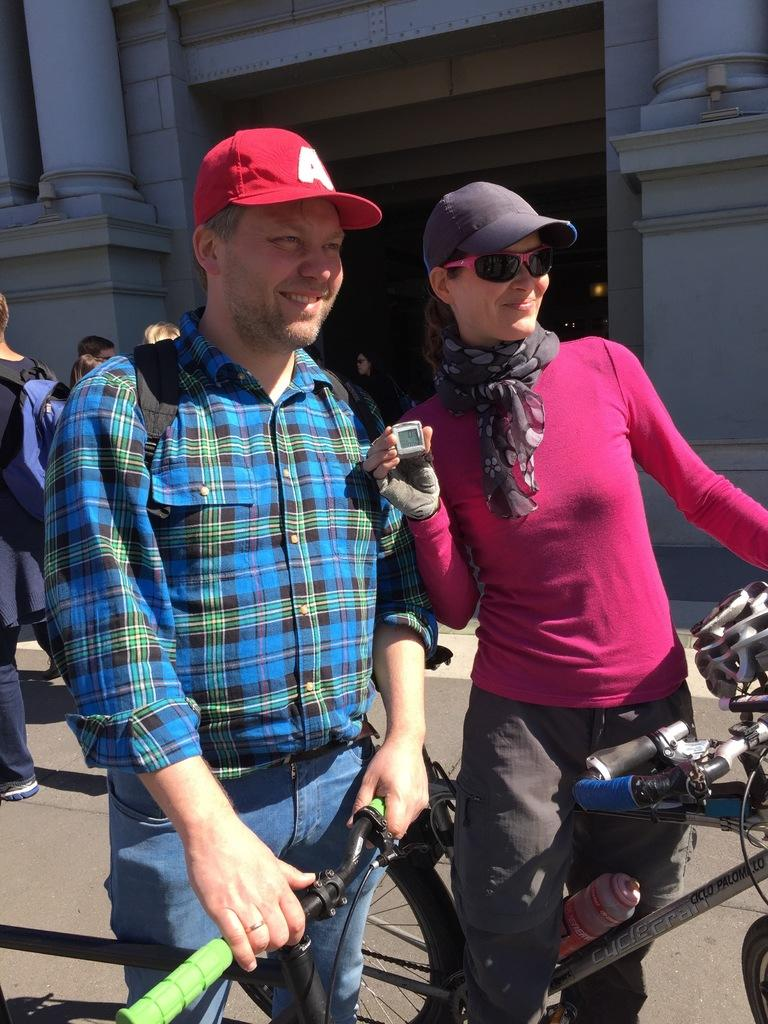How many people are standing in the image? There are 2 people standing in the image. What are the people wearing on their heads? The people are wearing caps. What are the people holding in the image? The people are holding bicycles. Can you describe the other people in the image? There are other people in the image, but their specific actions or features are not mentioned in the provided facts. What type of structure is visible in the image? There is a building in the image, and it has pillars. What type of game is being played by the people in the image? There is no indication in the image that a game is being played; the people are simply standing and holding bicycles. What type of iron is visible in the image? There is no iron present in the image. 